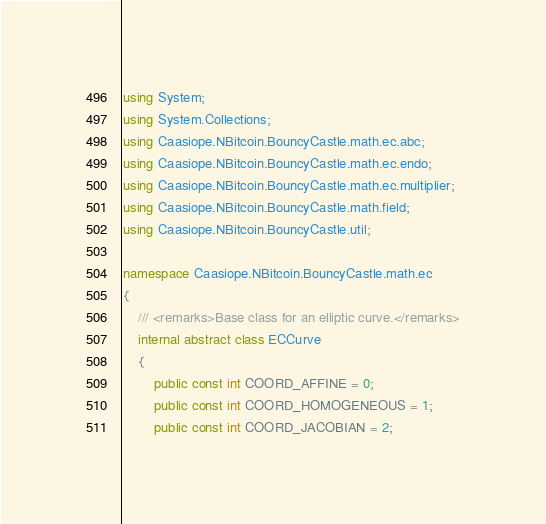<code> <loc_0><loc_0><loc_500><loc_500><_C#_>using System;
using System.Collections;
using Caasiope.NBitcoin.BouncyCastle.math.ec.abc;
using Caasiope.NBitcoin.BouncyCastle.math.ec.endo;
using Caasiope.NBitcoin.BouncyCastle.math.ec.multiplier;
using Caasiope.NBitcoin.BouncyCastle.math.field;
using Caasiope.NBitcoin.BouncyCastle.util;

namespace Caasiope.NBitcoin.BouncyCastle.math.ec
{
	/// <remarks>Base class for an elliptic curve.</remarks>
	internal abstract class ECCurve
	{
		public const int COORD_AFFINE = 0;
		public const int COORD_HOMOGENEOUS = 1;
		public const int COORD_JACOBIAN = 2;</code> 